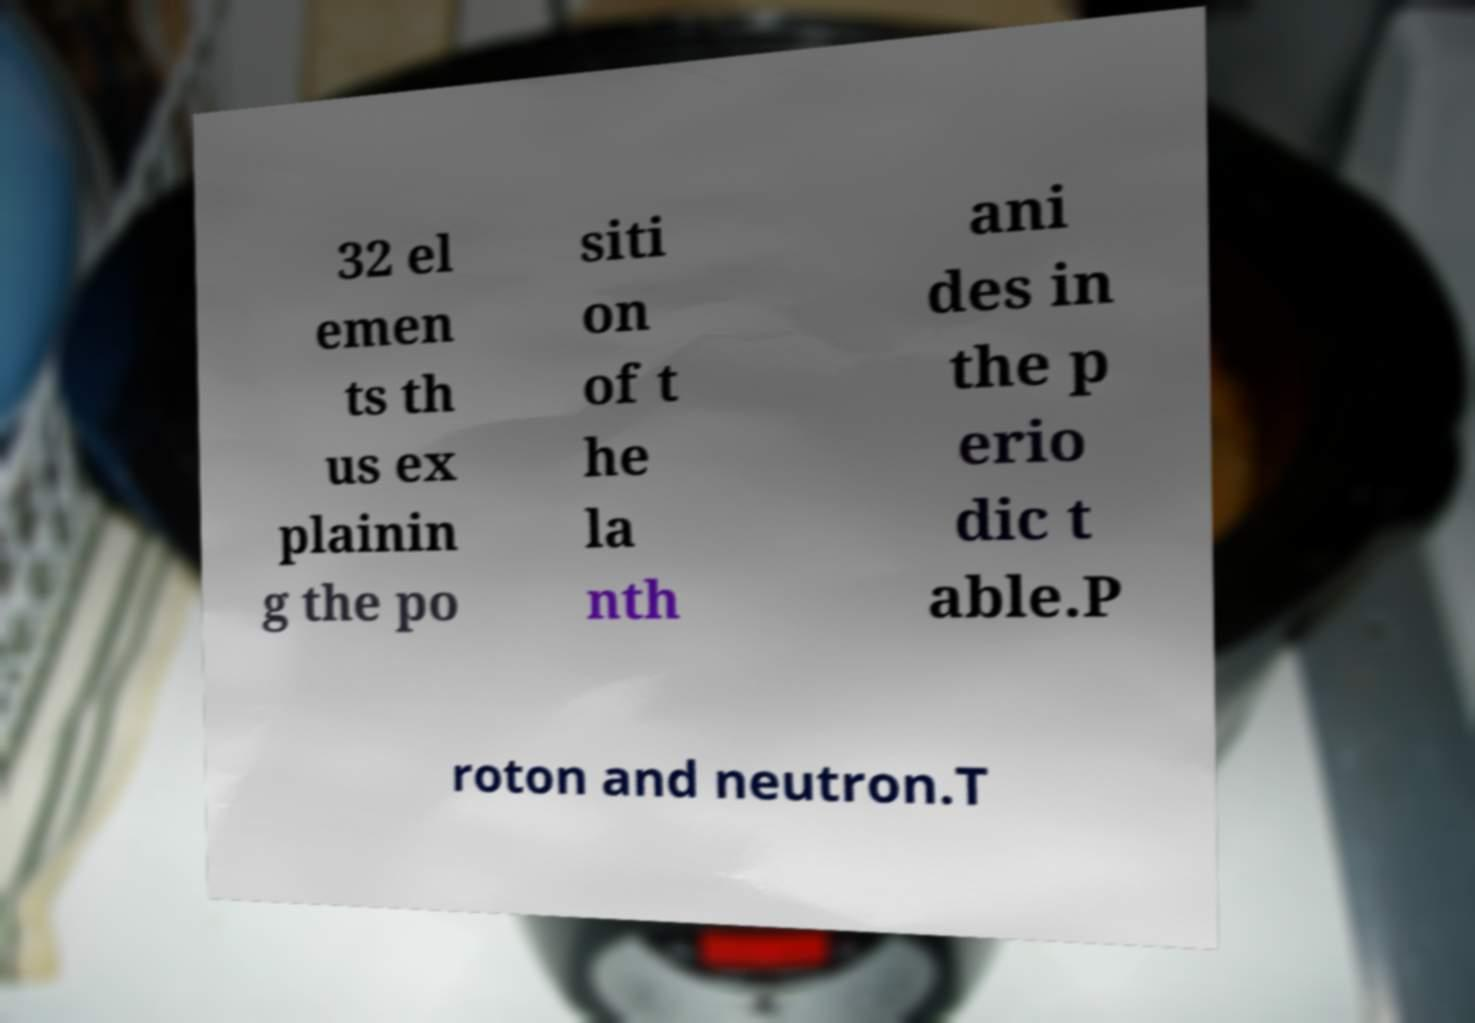Can you read and provide the text displayed in the image?This photo seems to have some interesting text. Can you extract and type it out for me? 32 el emen ts th us ex plainin g the po siti on of t he la nth ani des in the p erio dic t able.P roton and neutron.T 